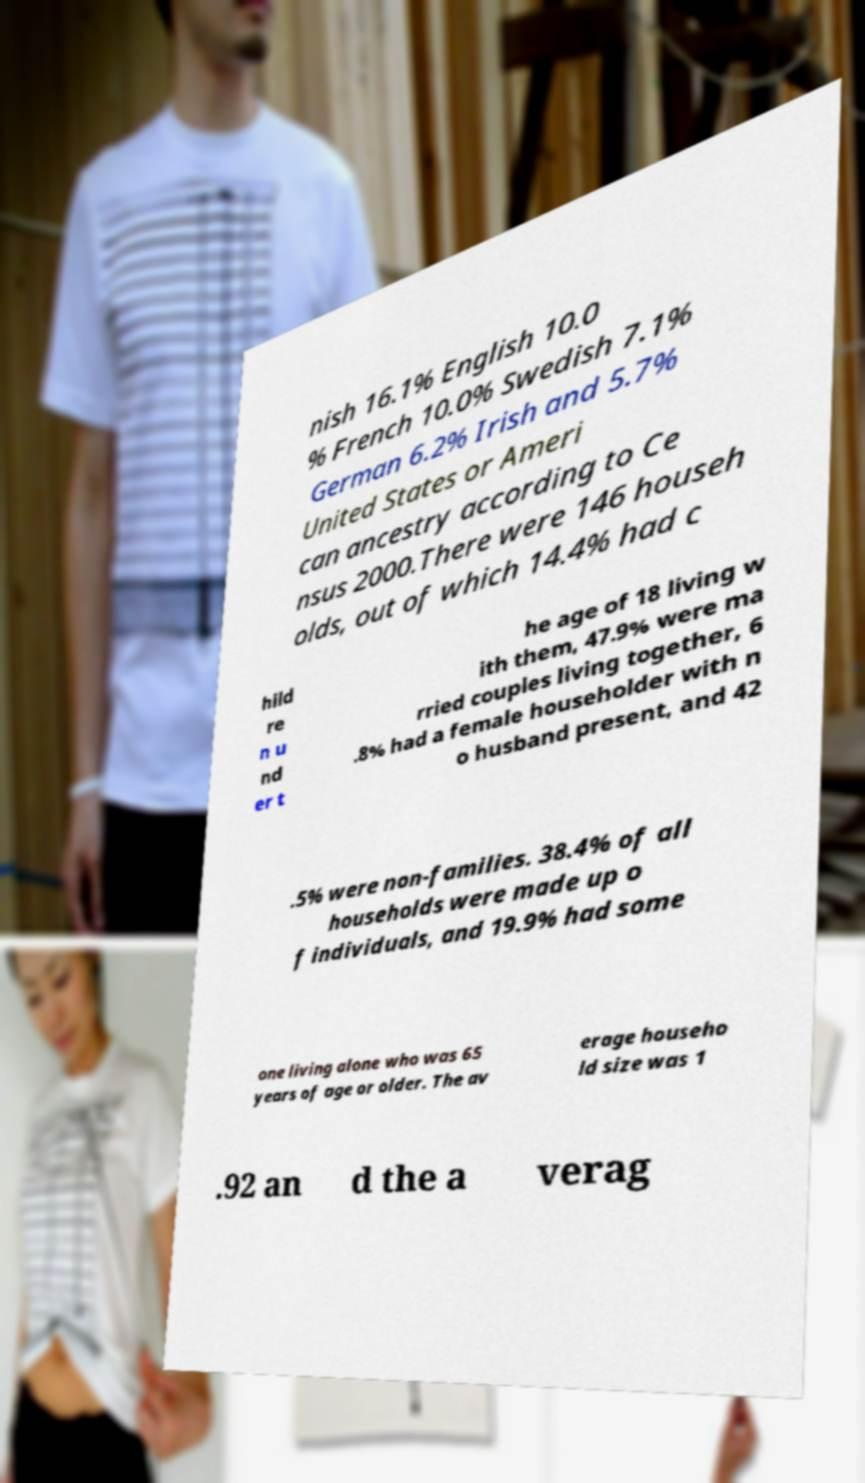Can you read and provide the text displayed in the image?This photo seems to have some interesting text. Can you extract and type it out for me? nish 16.1% English 10.0 % French 10.0% Swedish 7.1% German 6.2% Irish and 5.7% United States or Ameri can ancestry according to Ce nsus 2000.There were 146 househ olds, out of which 14.4% had c hild re n u nd er t he age of 18 living w ith them, 47.9% were ma rried couples living together, 6 .8% had a female householder with n o husband present, and 42 .5% were non-families. 38.4% of all households were made up o f individuals, and 19.9% had some one living alone who was 65 years of age or older. The av erage househo ld size was 1 .92 an d the a verag 